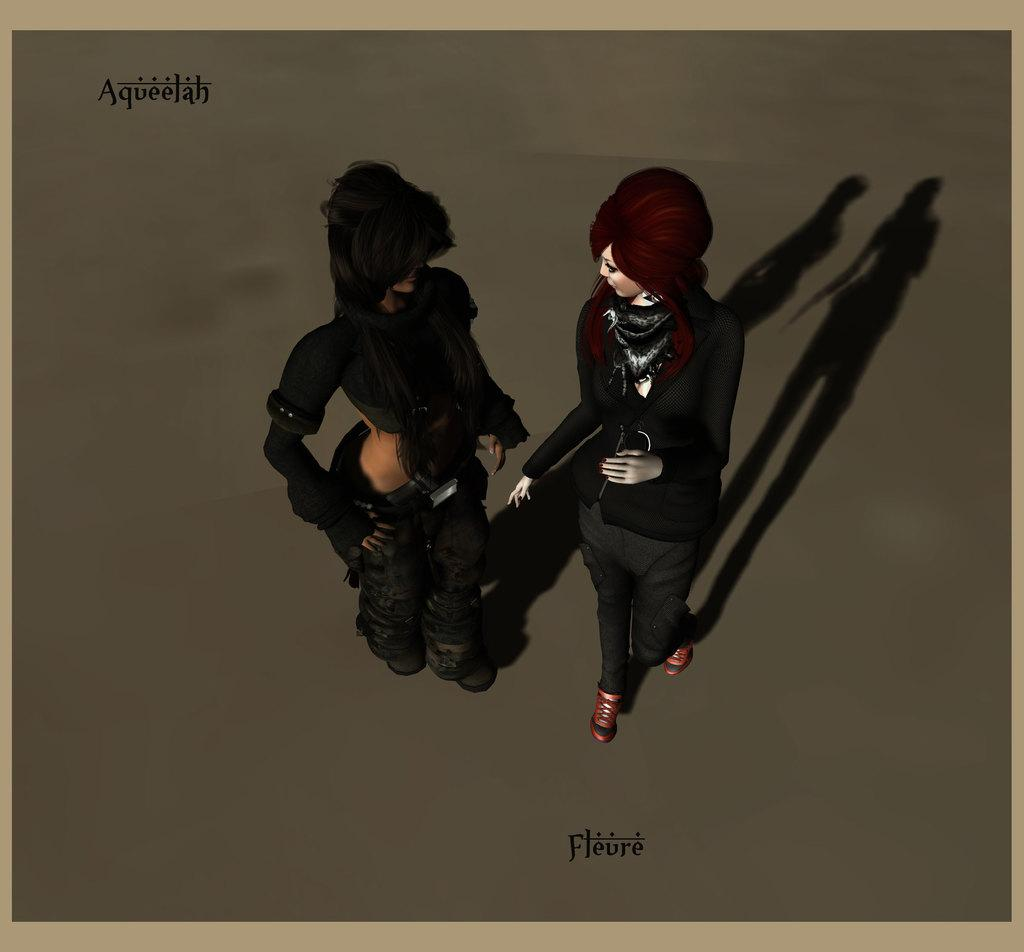What type of visual content is depicted in the image? The image is an animation. How many people are present in the image? There are three people in the image. Where can text be found in the image? There is text written in the top left corner and at the bottom of the image. What type of bead is being used to cook the chickens in the image? There are no beads or chickens present in the image; it is an animation featuring three people. What type of breakfast is being prepared in the image? There is no breakfast preparation depicted in the image; it is an animation with three people and text. 